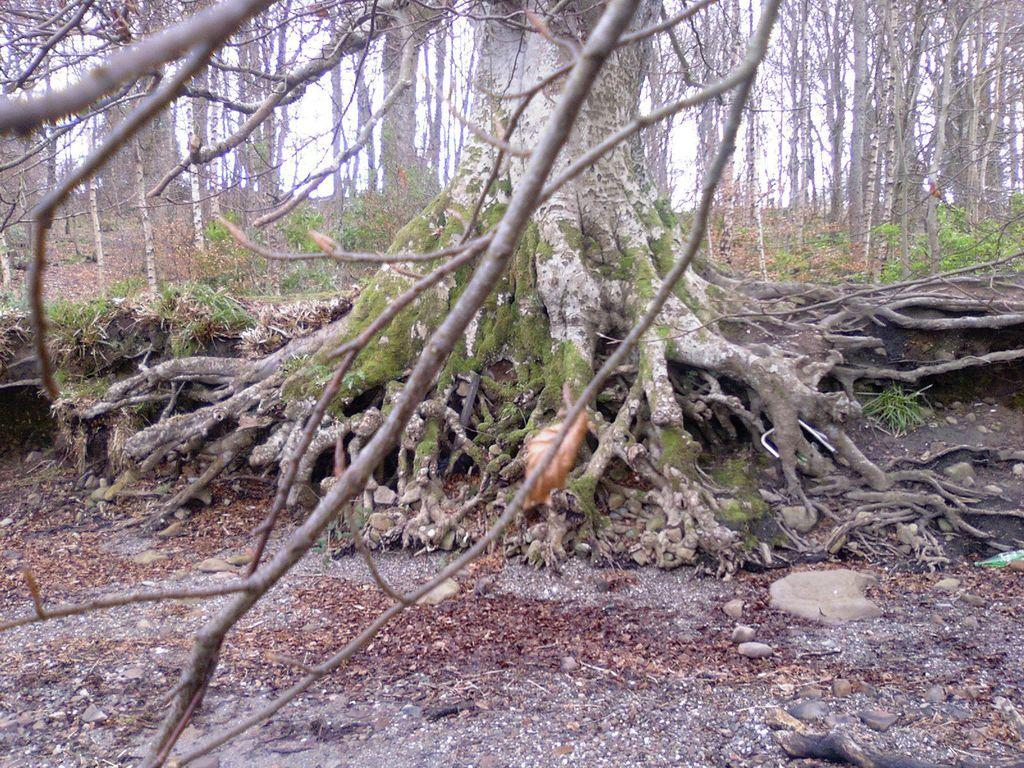What type of vegetation can be seen in the image? There are trees and plants in the image. What is covering the ground in the image? Dry leaves are present on the ground. What type of school can be seen in the image? There is no school present in the image; it features trees, plants, and dry leaves on the ground. 